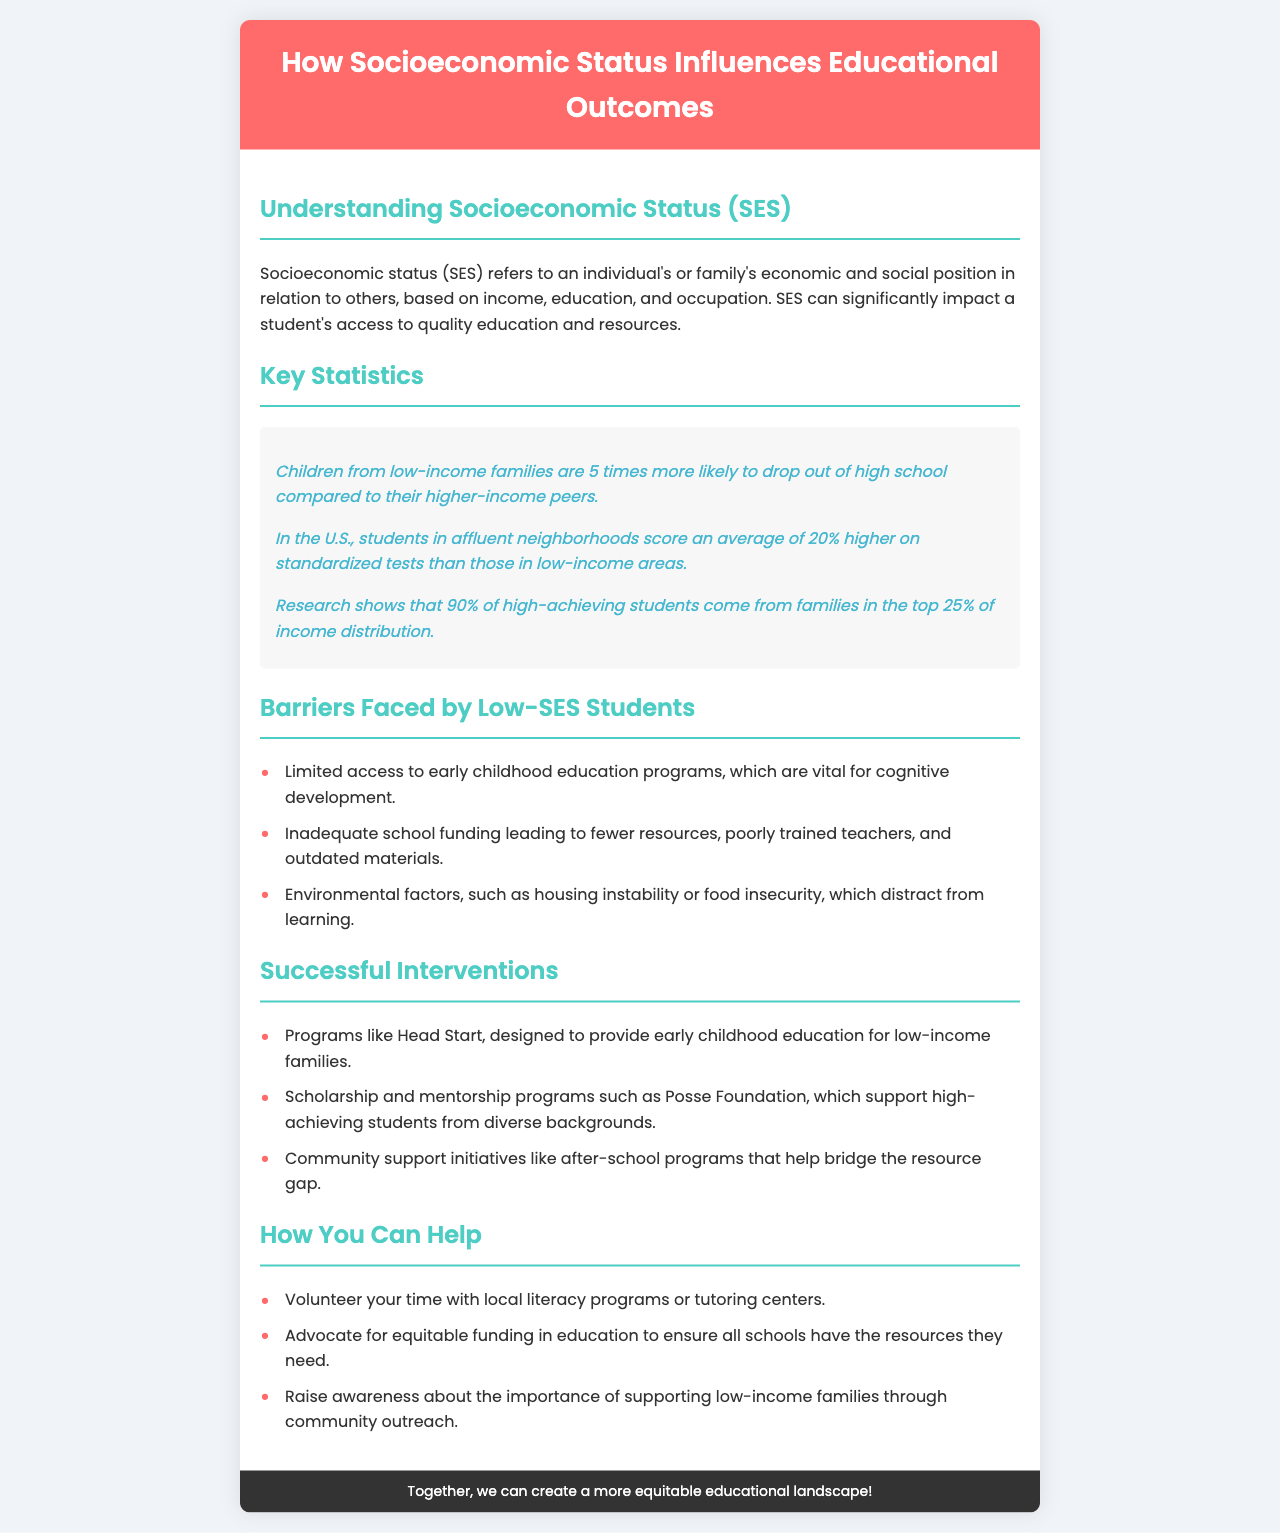What does SES stand for? SES stands for socioeconomic status, which is explained in the document as an individual's or family's economic and social position.
Answer: Socioeconomic status How much more likely are low-income children to drop out of high school? The document states that children from low-income families are 5 times more likely to drop out of high school compared to higher-income peers.
Answer: 5 times What average score difference is noted between affluent and low-income areas on standardized tests? The document mentions a 20% higher average score for students in affluent neighborhoods compared to those in low-income areas.
Answer: 20% Name one barrier faced by low-SES students. The document lists several barriers, such as limited access to early childhood education programs.
Answer: Limited access to early childhood education What is an example of a successful intervention mentioned? The document provides examples like the Head Start program, designed for early childhood education for low-income families.
Answer: Head Start How can individuals help according to the brochure? The brochure suggests volunteering time with local literacy programs or tutoring centers as one way individuals can help.
Answer: Volunteer your time What percentage of high-achieving students come from the top 25% of income distribution? According to the document, research shows that 90% of high-achieving students come from the top 25% of income distribution.
Answer: 90% What is the overall goal of the brochure? The document emphasizes creating a more equitable educational landscape as the overall goal of the brochure.
Answer: A more equitable educational landscape 